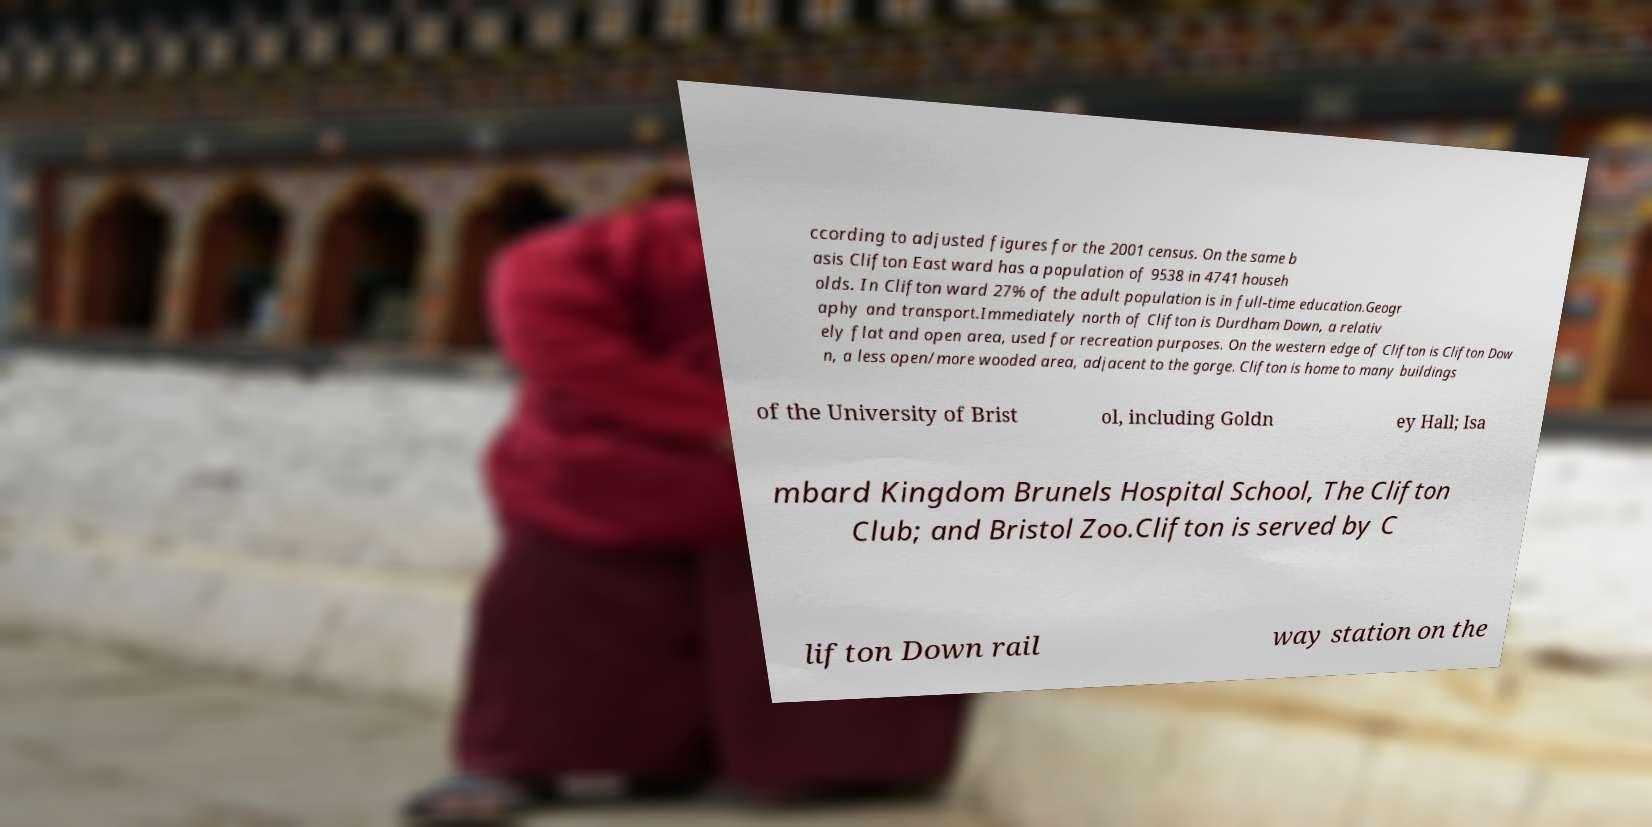Can you accurately transcribe the text from the provided image for me? ccording to adjusted figures for the 2001 census. On the same b asis Clifton East ward has a population of 9538 in 4741 househ olds. In Clifton ward 27% of the adult population is in full-time education.Geogr aphy and transport.Immediately north of Clifton is Durdham Down, a relativ ely flat and open area, used for recreation purposes. On the western edge of Clifton is Clifton Dow n, a less open/more wooded area, adjacent to the gorge. Clifton is home to many buildings of the University of Brist ol, including Goldn ey Hall; Isa mbard Kingdom Brunels Hospital School, The Clifton Club; and Bristol Zoo.Clifton is served by C lifton Down rail way station on the 